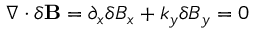<formula> <loc_0><loc_0><loc_500><loc_500>\nabla \cdot \delta B = \partial _ { x } \delta B _ { x } + k _ { y } \delta B _ { y } = 0</formula> 